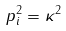<formula> <loc_0><loc_0><loc_500><loc_500>p _ { i } ^ { 2 } = \kappa ^ { 2 }</formula> 